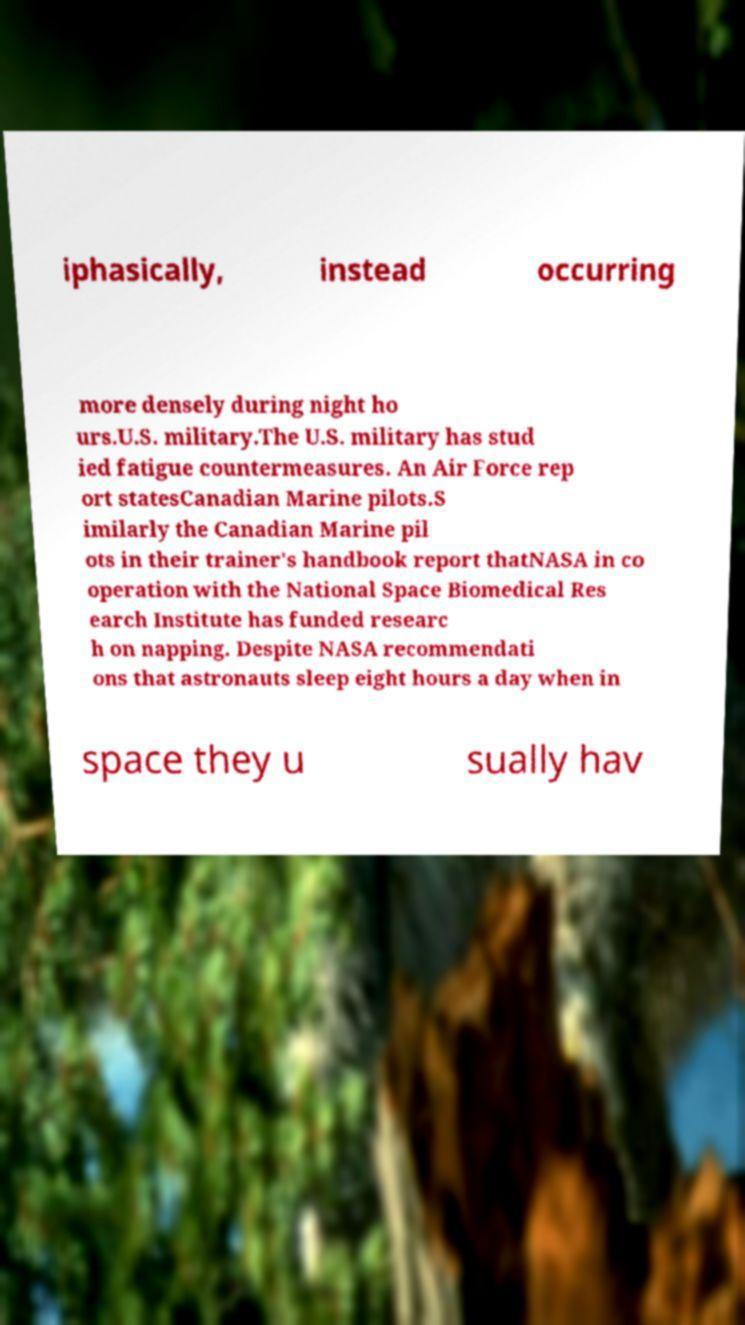What messages or text are displayed in this image? I need them in a readable, typed format. iphasically, instead occurring more densely during night ho urs.U.S. military.The U.S. military has stud ied fatigue countermeasures. An Air Force rep ort statesCanadian Marine pilots.S imilarly the Canadian Marine pil ots in their trainer's handbook report thatNASA in co operation with the National Space Biomedical Res earch Institute has funded researc h on napping. Despite NASA recommendati ons that astronauts sleep eight hours a day when in space they u sually hav 